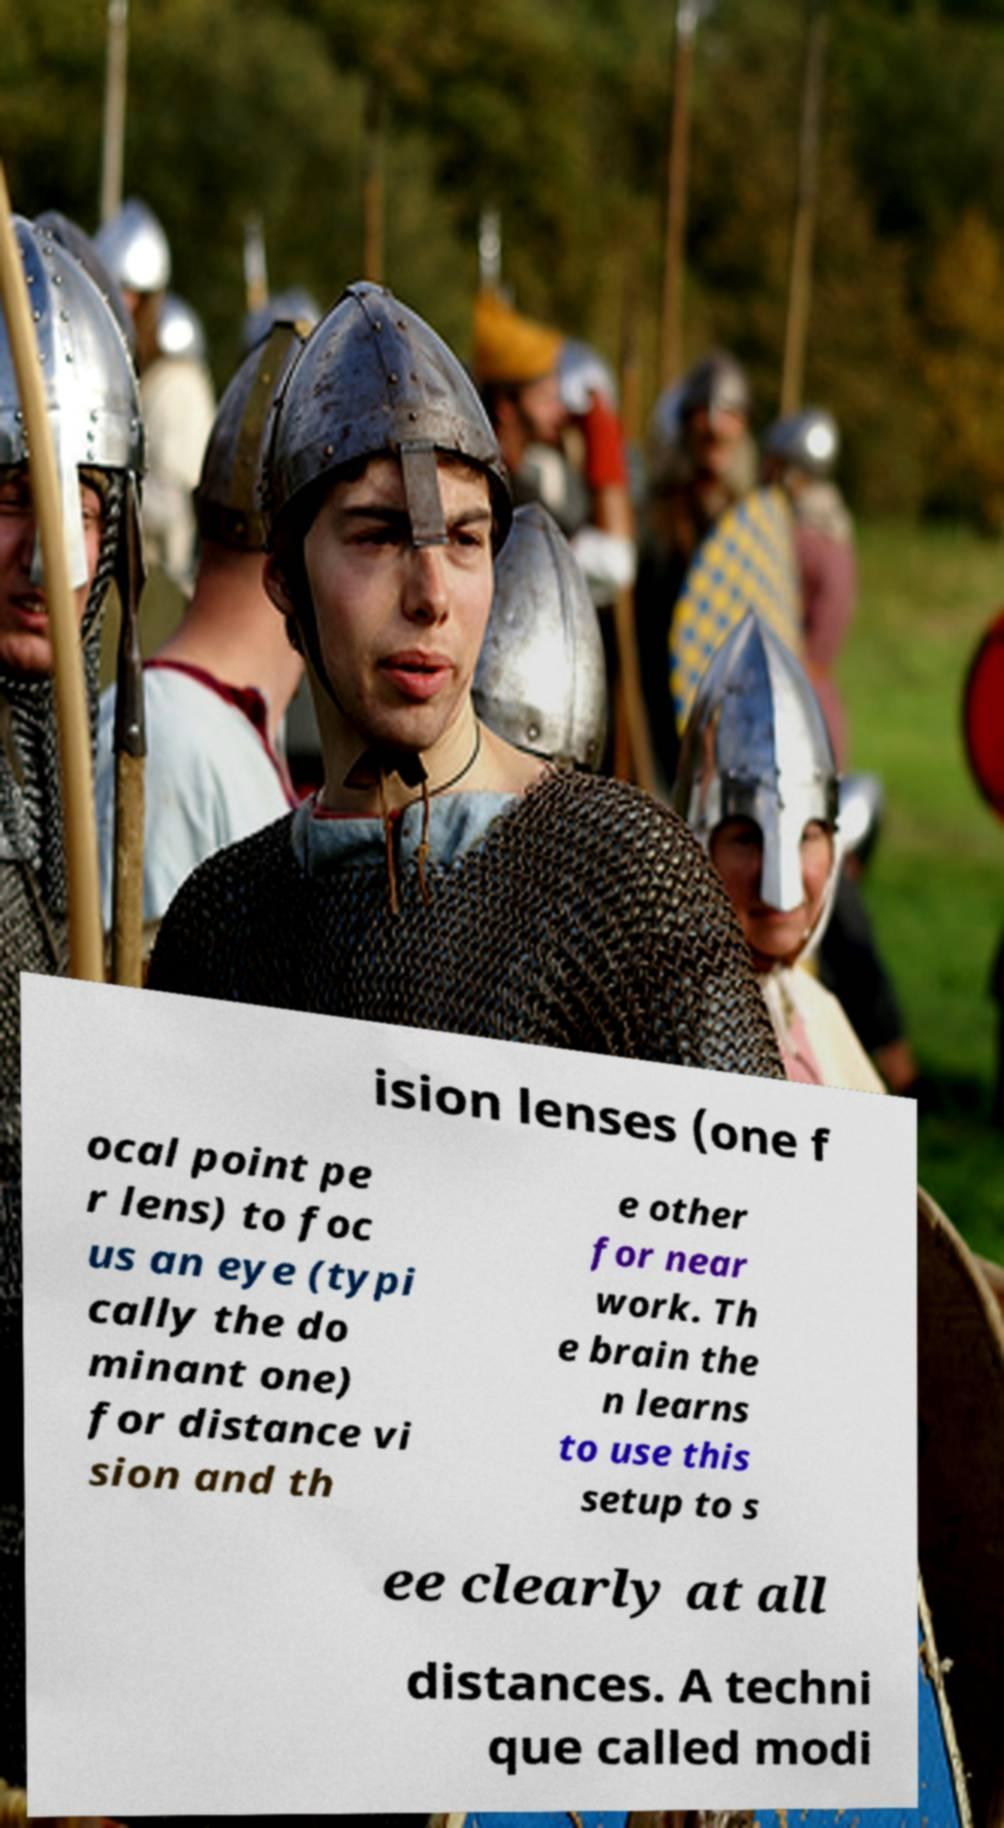Please identify and transcribe the text found in this image. ision lenses (one f ocal point pe r lens) to foc us an eye (typi cally the do minant one) for distance vi sion and th e other for near work. Th e brain the n learns to use this setup to s ee clearly at all distances. A techni que called modi 